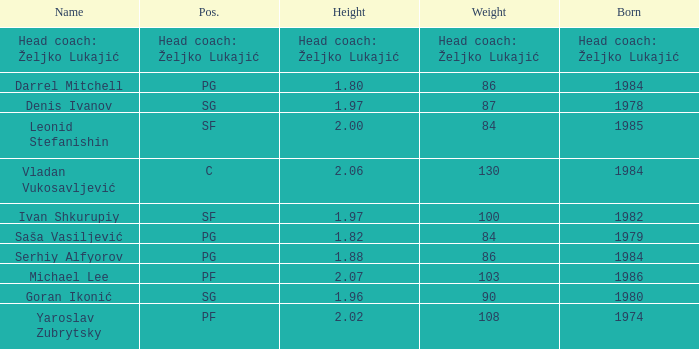What is the position of the player born in 1984 with a height of 1.80m? PG. 